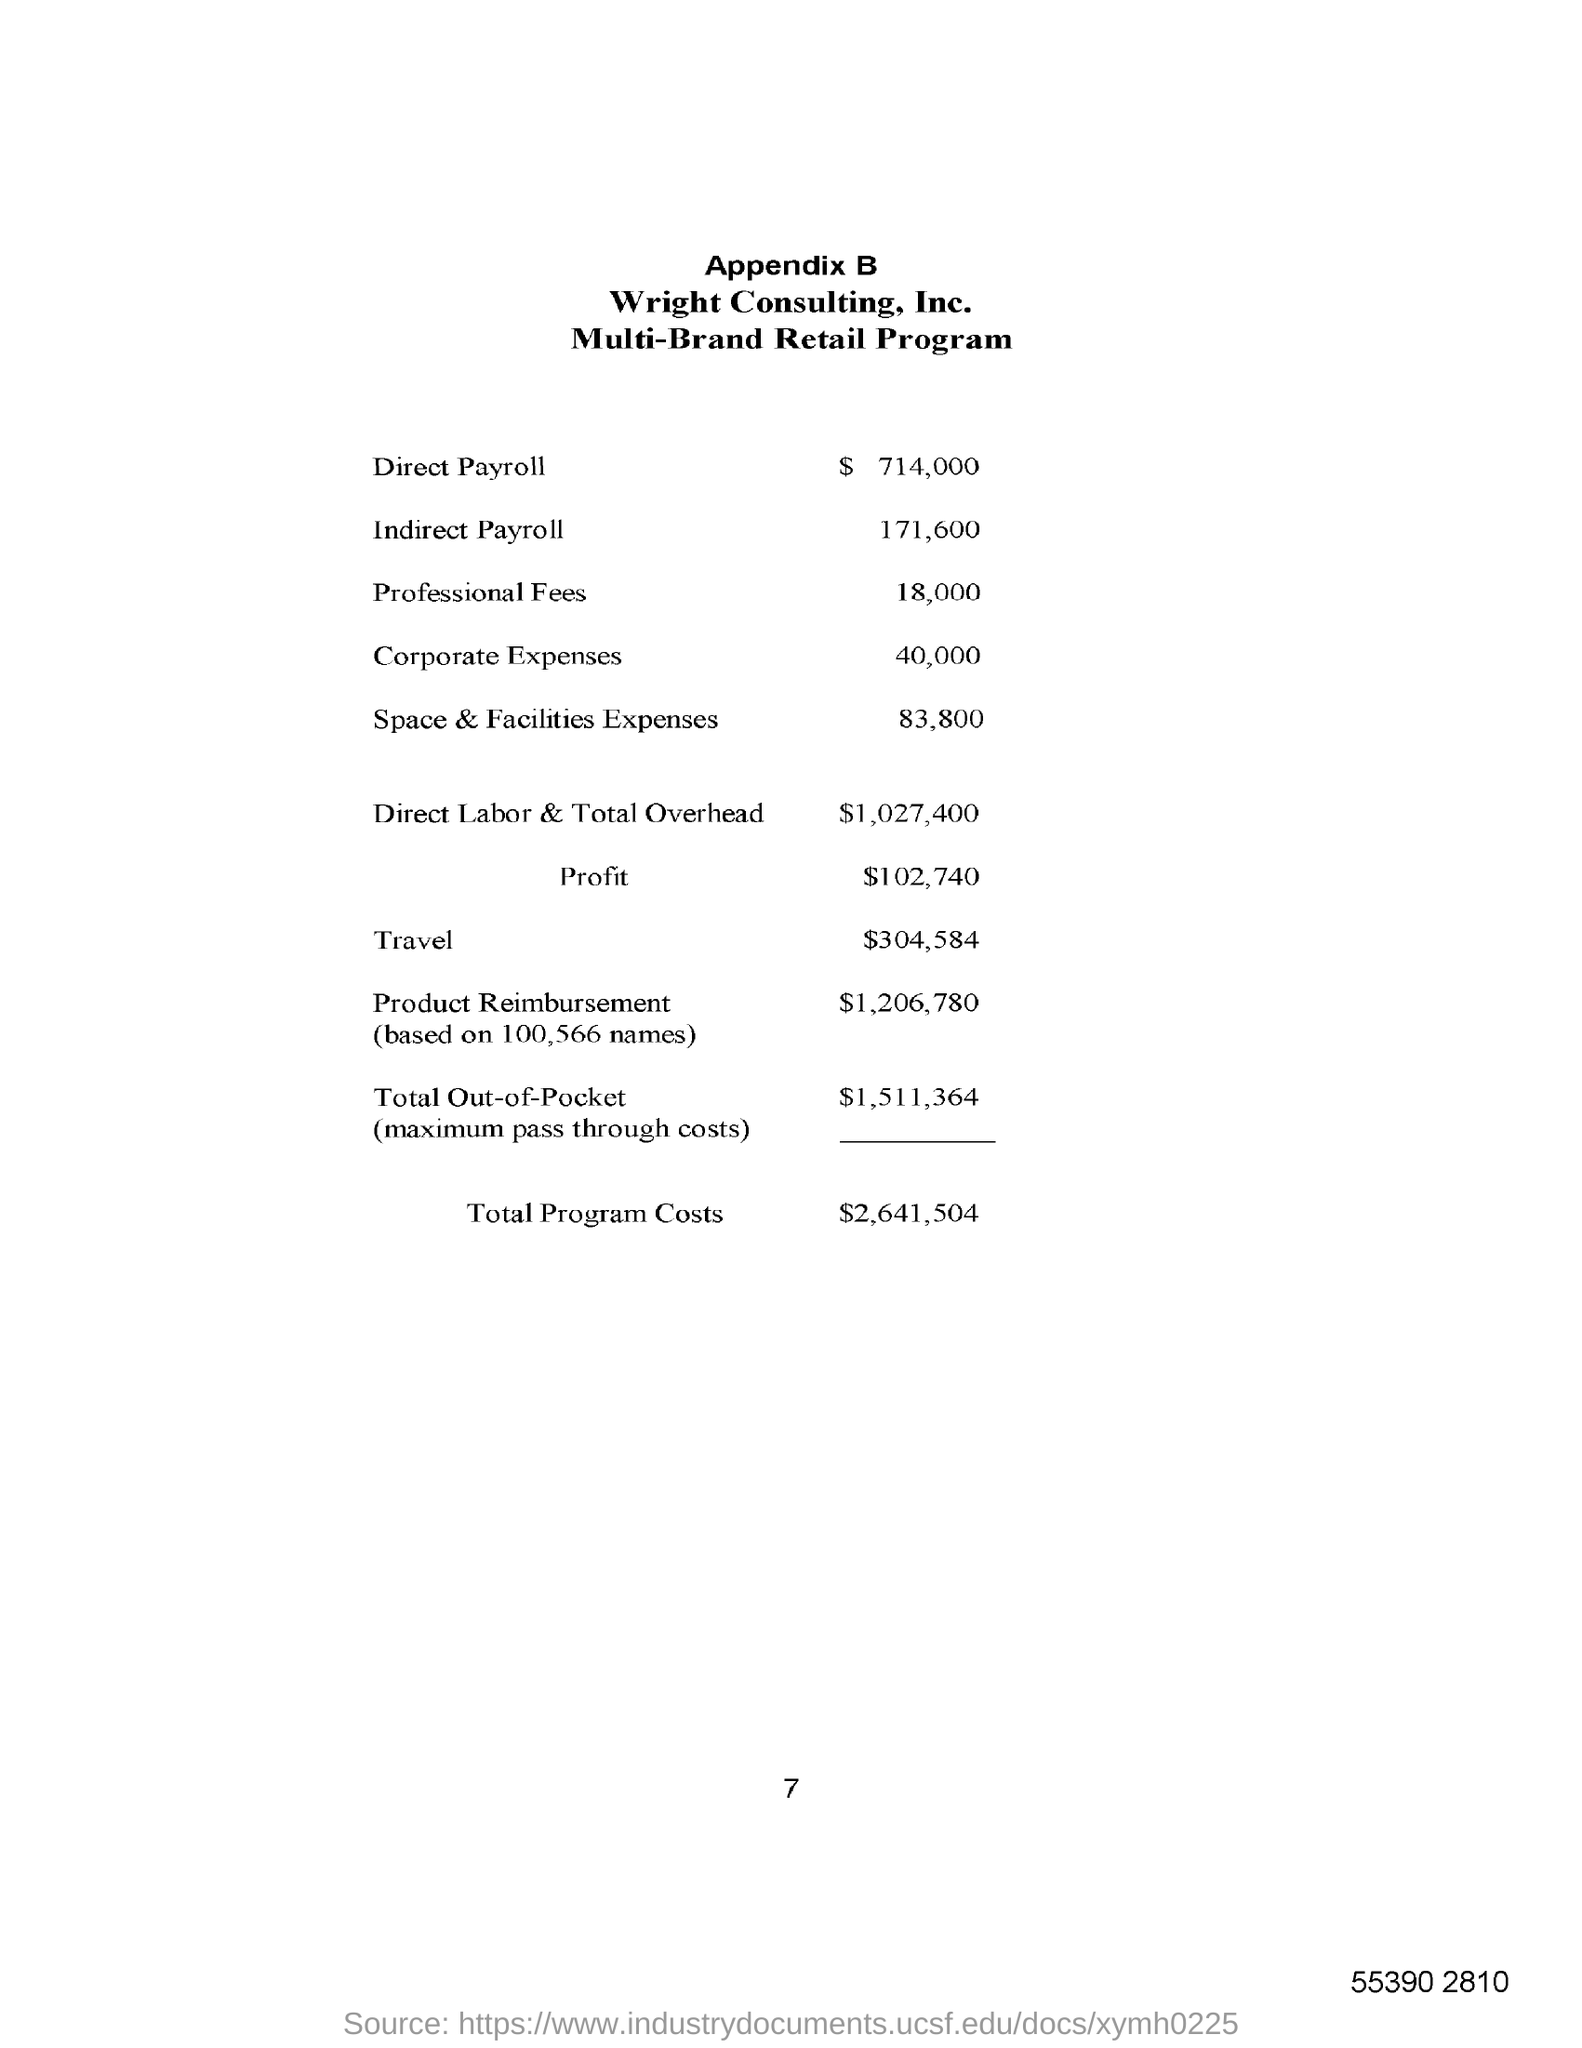Specify some key components in this picture. Direct labor costs and total overhead for the month of May amounted to $1,027,400. The direct payroll amount is $714,000. Our profit for the year is $102,740. The total program costs are $2,641,504. 